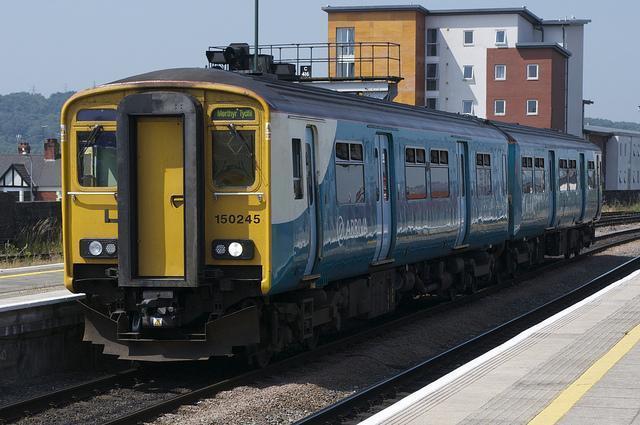How many doors are on the side of the train?
Give a very brief answer. 6. 